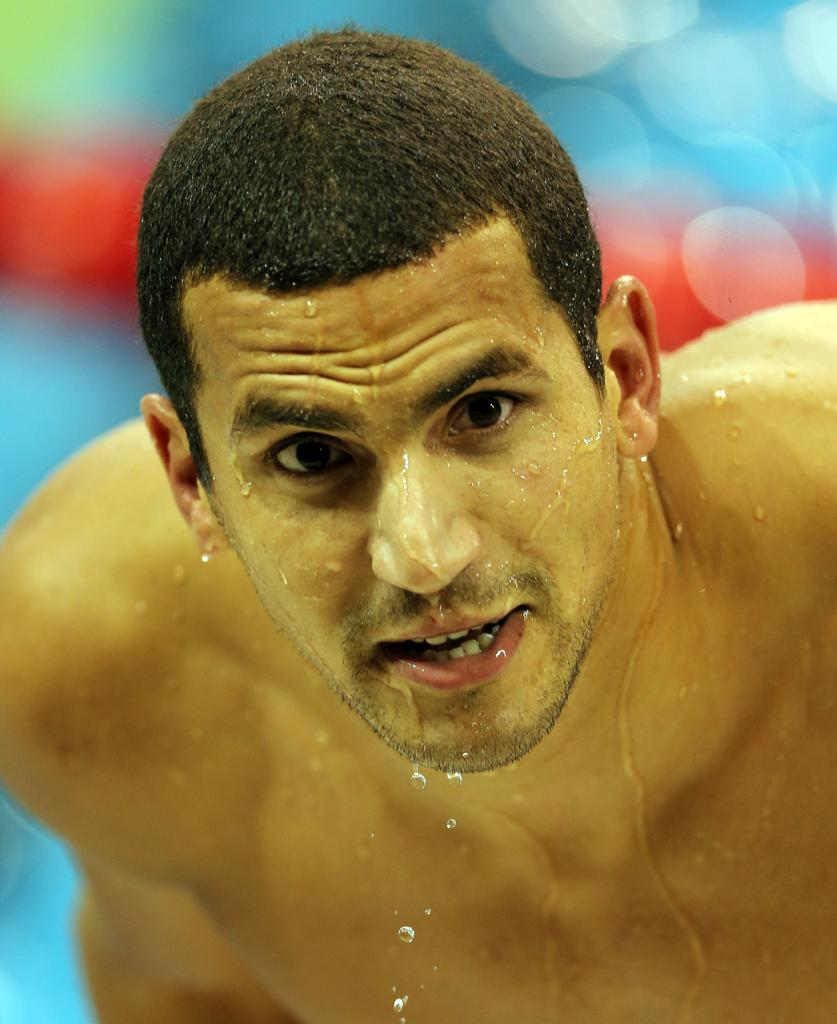Who is the main subject in the image? There is a man in the image. What can be observed on the man's body and face? Water droplets are visible on the man's body and face. Can you describe the background of the image? The background of the image is blurry. What type of cover is protecting the stove in the image? There is no stove present in the image, so there is no cover to protect it. 